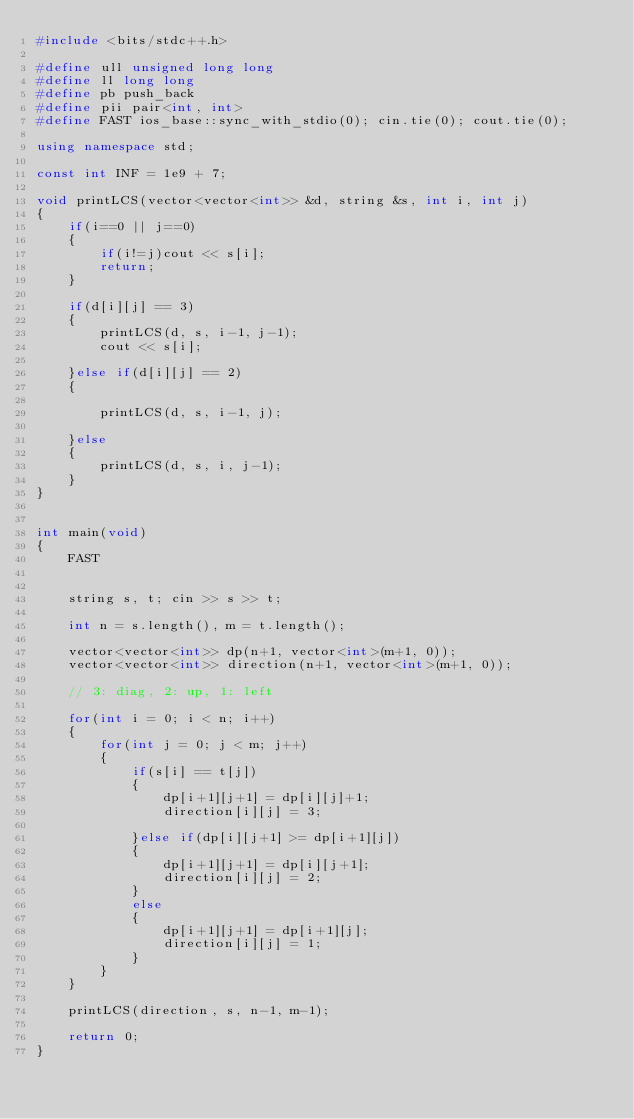Convert code to text. <code><loc_0><loc_0><loc_500><loc_500><_C++_>#include <bits/stdc++.h>

#define ull unsigned long long
#define ll long long
#define pb push_back
#define pii pair<int, int>
#define FAST ios_base::sync_with_stdio(0); cin.tie(0); cout.tie(0);

using namespace std;

const int INF = 1e9 + 7;

void printLCS(vector<vector<int>> &d, string &s, int i, int j)
{
	if(i==0 || j==0)
	{
		if(i!=j)cout << s[i];
		return;
	}
	
	if(d[i][j] == 3)
	{
		printLCS(d, s, i-1, j-1);
		cout << s[i];
	
	}else if(d[i][j] == 2)
	{
		
		printLCS(d, s, i-1, j);
		
	}else
	{
		printLCS(d, s, i, j-1);
	}
}
	

int main(void)
{
	FAST
	
	
	string s, t; cin >> s >> t;
	
	int n = s.length(), m = t.length();
	
	vector<vector<int>> dp(n+1, vector<int>(m+1, 0));
	vector<vector<int>> direction(n+1, vector<int>(m+1, 0));
	
	// 3: diag, 2: up, 1: left
	
	for(int i = 0; i < n; i++)
	{
		for(int j = 0; j < m; j++)
		{
			if(s[i] == t[j])
			{
				dp[i+1][j+1] = dp[i][j]+1;
				direction[i][j] = 3;
				
			}else if(dp[i][j+1] >= dp[i+1][j])
			{
				dp[i+1][j+1] = dp[i][j+1];
				direction[i][j] = 2;
			}
			else
			{
				dp[i+1][j+1] = dp[i+1][j];
				direction[i][j] = 1;
			}
		}
	}
	
	printLCS(direction, s, n-1, m-1);
	
	return 0;
}
</code> 